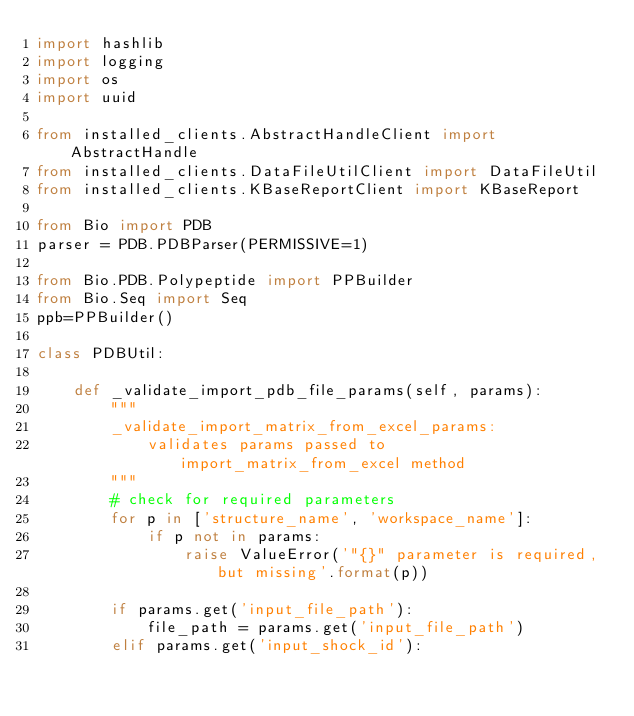Convert code to text. <code><loc_0><loc_0><loc_500><loc_500><_Python_>import hashlib
import logging
import os
import uuid

from installed_clients.AbstractHandleClient import AbstractHandle
from installed_clients.DataFileUtilClient import DataFileUtil
from installed_clients.KBaseReportClient import KBaseReport

from Bio import PDB
parser = PDB.PDBParser(PERMISSIVE=1)

from Bio.PDB.Polypeptide import PPBuilder
from Bio.Seq import Seq
ppb=PPBuilder()

class PDBUtil:

    def _validate_import_pdb_file_params(self, params):
        """
        _validate_import_matrix_from_excel_params:
            validates params passed to import_matrix_from_excel method
        """
        # check for required parameters
        for p in ['structure_name', 'workspace_name']:
            if p not in params:
                raise ValueError('"{}" parameter is required, but missing'.format(p))

        if params.get('input_file_path'):
            file_path = params.get('input_file_path')
        elif params.get('input_shock_id'):</code> 